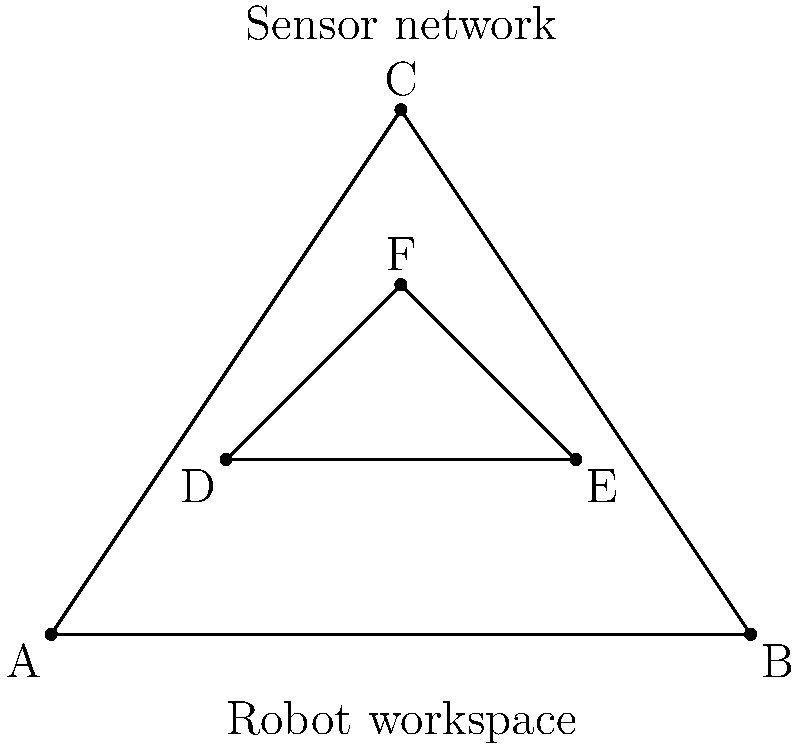In the diagram, triangle ABC represents a robot's workspace, while triangle DEF represents a network of safety sensors. If the optimal sensor arrangement requires maximizing the area ratio between the sensor network and the workspace, what is this ratio? To solve this problem, we need to follow these steps:

1. Calculate the area of triangle ABC (workspace):
   Area ABC = $\frac{1}{2} \times base \times height$
   Base = 4 units
   Height = 3 units
   Area ABC = $\frac{1}{2} \times 4 \times 3 = 6$ square units

2. Calculate the area of triangle DEF (sensor network):
   Area DEF = $\frac{1}{2} \times base \times height$
   Base = 2 units
   Height = 1 unit
   Area DEF = $\frac{1}{2} \times 2 \times 1 = 1$ square unit

3. Calculate the ratio of sensor network area to workspace area:
   Ratio = $\frac{Area DEF}{Area ABC} = \frac{1}{6}$

4. Express the ratio as a percentage:
   Percentage = $\frac{1}{6} \times 100\% = 16.67\%$

The optimal sensor arrangement results in a coverage ratio of 16.67% of the workspace area.
Answer: 16.67% 